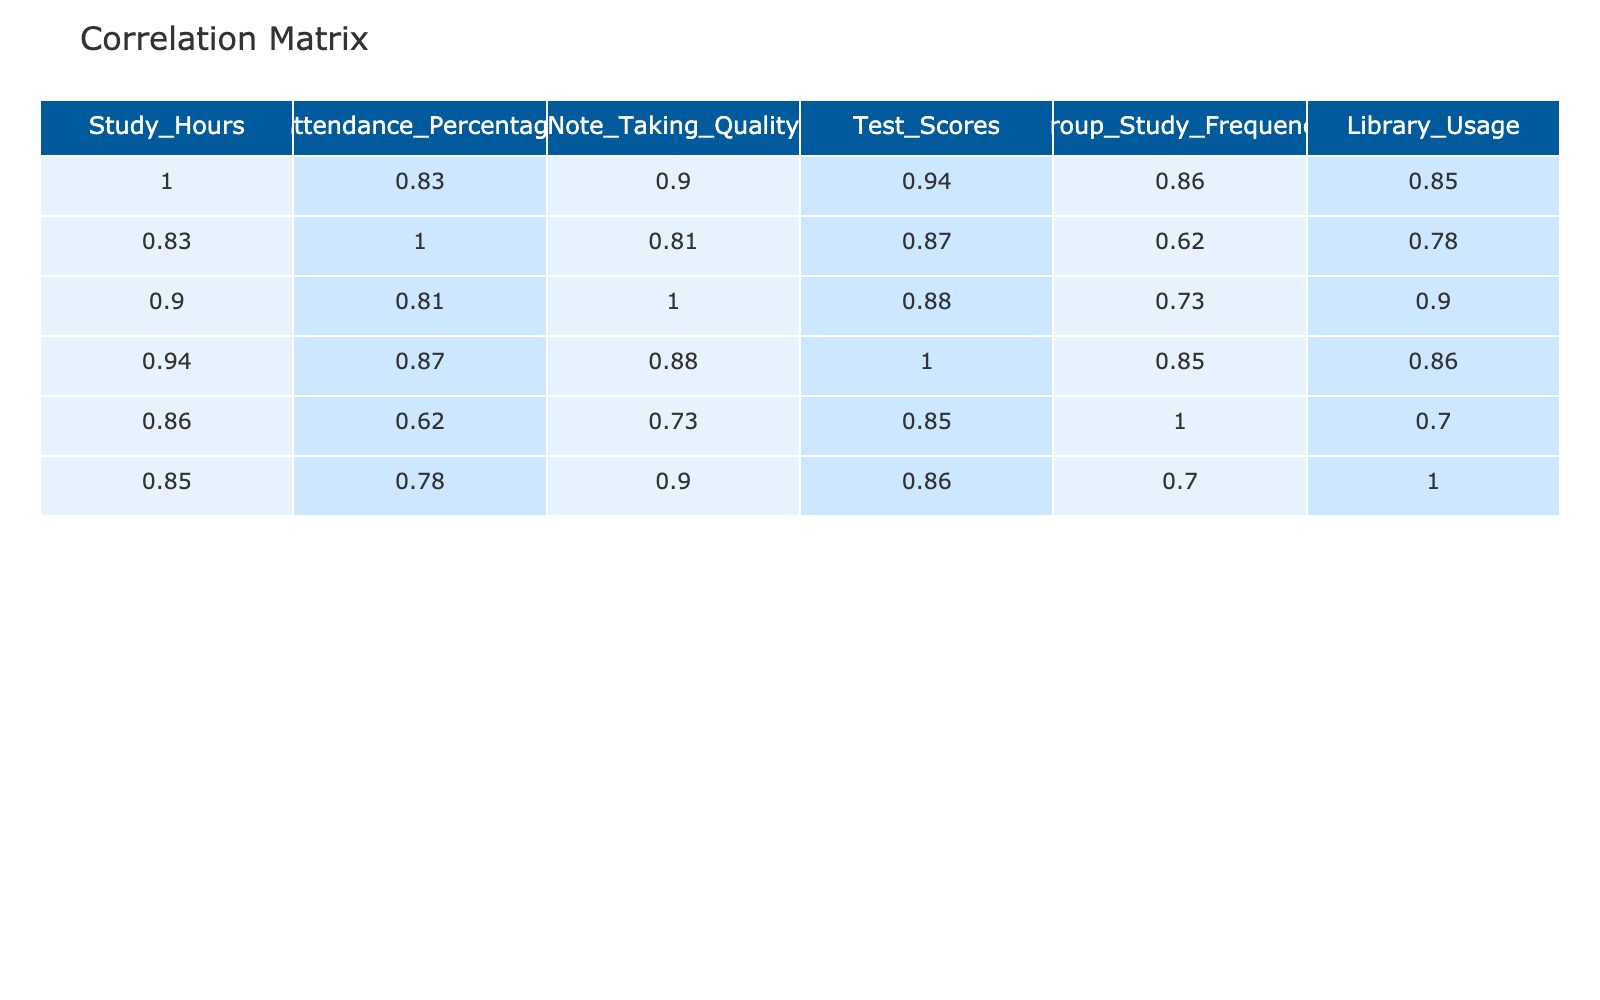What is the correlation coefficient between study hours and test scores? The correlation coefficient between study hours and test scores can be directly read from the table, which shows a value of 0.95. This indicates a strong positive correlation.
Answer: 0.95 What is the average attendance percentage of students who study more than 15 hours a week? The students who study more than 15 hours are: 20 (95%), 18 (88%), and 19 (93%). Their attendance percentages are summed up: 95 + 88 + 93 = 276. Dividing by the number of students (3), the average is 276 / 3 = 92.
Answer: 92 Is there a negative correlation between library usage and test scores? The correlation coefficient between library usage and test scores is 0.88, which is positive, indicating that there is no negative correlation.
Answer: No How many students have a test score above 80 and study more than 15 hours a week? The students with a test score above 80 and study hours more than 15 are: 20 (95), 18 (88), and 19 (94). Counting these, there are three students.
Answer: 3 What is the difference between the highest and lowest note-taking quality? The highest note-taking quality is 10, and the lowest is 5. To find the difference, subtract the lowest from the highest: 10 - 5 = 5.
Answer: 5 Is there a correlation between group study frequency and note-taking quality? The table shows a correlation coefficient of -0.23 between group study frequency and note-taking quality. Since this value is below zero, it indicates a negative correlation.
Answer: Yes What is the overall average of study hours among all students? The study hours for all students are: 15, 10, 20, 12, 18, 14, 9, 17, 11, 19. Summing these gives 15 + 10 + 20 + 12 + 18 + 14 + 9 + 17 + 11 + 19 =  175. There are 10 students, so the average is 175 / 10 = 17.5.
Answer: 17.5 How many students scored below 75 on their tests? The test scores below 75 are: 75 (1 student), 70 (1 student), 65 (1 student), and lower. Counting these students gives a total of three students: 1 from 75, 1 from 70, and 1 from 65, totaling 3.
Answer: 3 